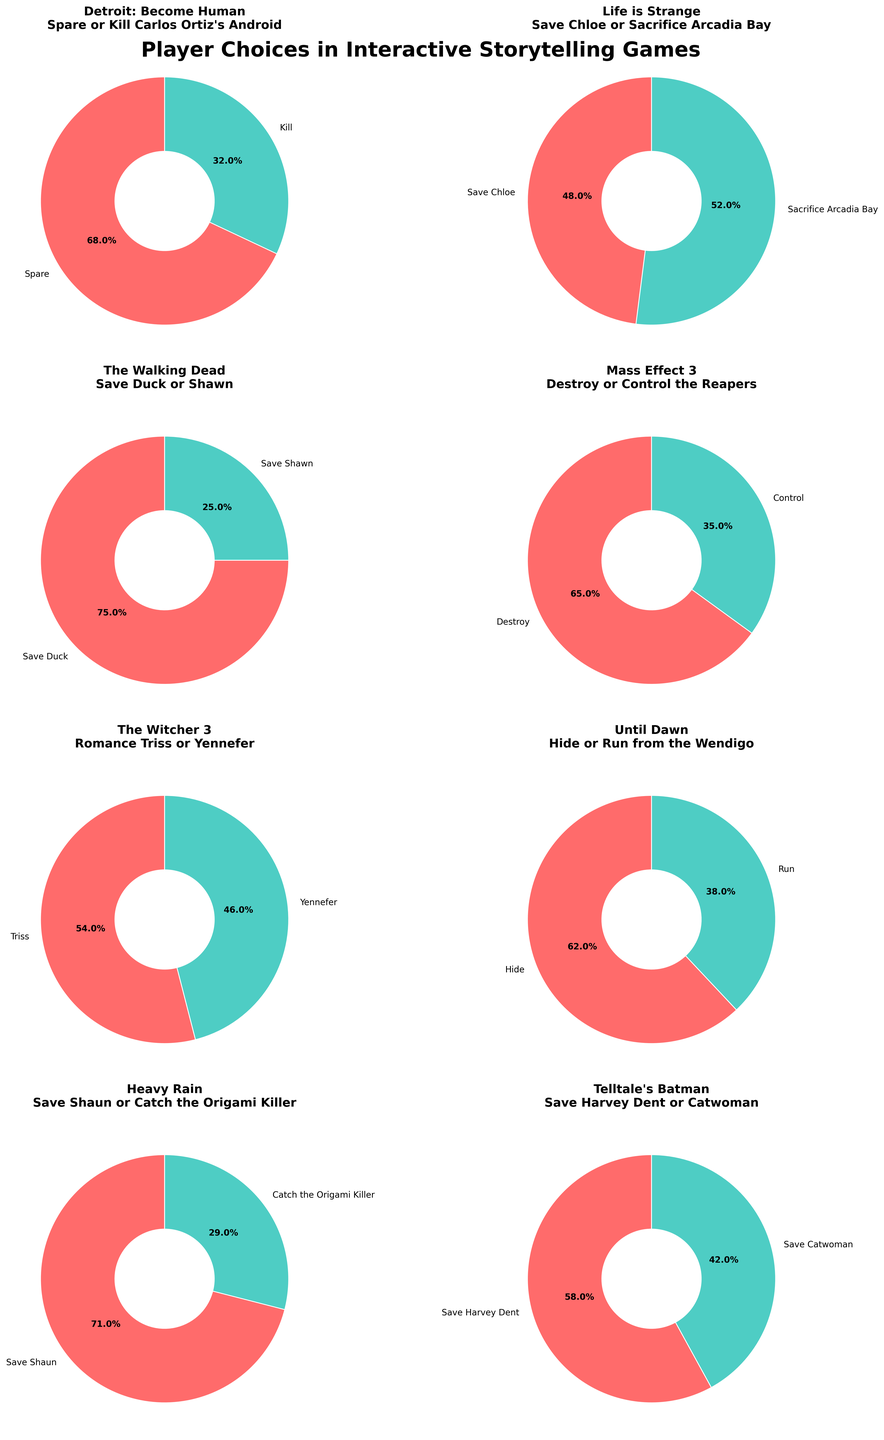What's the percentage of players who chose to spare Carlos Ortiz's Android in "Detroit: Become Human"? To find this, look at the pie chart corresponding to "Detroit: Become Human" and the key moment about sparing or killing Carlos Ortiz's Android. The chart shows the percentages for both choices.
Answer: 68% Which key moment had the closest distribution of player choices? Check each subplot to find the pie chart where the two choices have percentages closest to each other. The chart for "Life is Strange" discussing whether to save Chloe or sacrifice Arcadia Bay has percentages of 48% and 52%.
Answer: Save Chloe or Sacrifice Arcadia Bay In "Until Dawn," how many players chose to run from the Wendigo compared to those who chose to hide? Look at the chart for "Until Dawn" and observe the percentages for both choices. Then, compute the number of players based on the given percentages. 62% chose to hide, and 38% chose to run. The difference is 62 - 38.
Answer: 24% Which game had the highest percentage of players choosing one option over the other, and what was the percentage? Examine all the pie charts to identify the highest percentage for any given choice. The chart for "The Walking Dead" shows that 75% chose to save Duck.
Answer: The Walking Dead, 75% How do the player choices in "Mass Effect 3" compare to those in "Heavy Rain"? Compare the percentages in the charts for "Mass Effect 3" and "Heavy Rain." In "Mass Effect 3," 65% chose to destroy the Reapers, and 35% chose to control them. In "Heavy Rain," 71% chose to save Shaun, and 29% chose to catch the Origami Killer. Comparatively, "Heavy Rain" has a higher percentage for the primary choice than "Mass Effect 3."
Answer: "Heavy Rain" choices are more one-sided compared to "Mass Effect 3." What's the average percentage for choosing a specific option in all games? Sum the primary choices percentages from all games. The primary choices are: 68, 48, 75, 65, 54, 62, 71, 58. Sum them: 68+48+75+65+54+62+71+58 = 501. There are 8 primary choices, so the average is 501/8.
Answer: 62.6% What is the percentage difference between the players who chose to save Harvey Dent and those who chose to save Catwoman in Telltale's Batman? Look at the chart for "Telltale's Batman." The percentages are 58% for saving Harvey Dent and 42% for saving Catwoman. Subtract the smaller percentage from the larger one.
Answer: 16% Which game had the most balanced player choices between the two options provided? Find the pie chart where the percentages are closest to a 50/50 split. The game "Life is Strange" with 48% and 52% for saving Chloe or sacrificing Arcadia Bay is the most balanced.
Answer: Life is Strange 